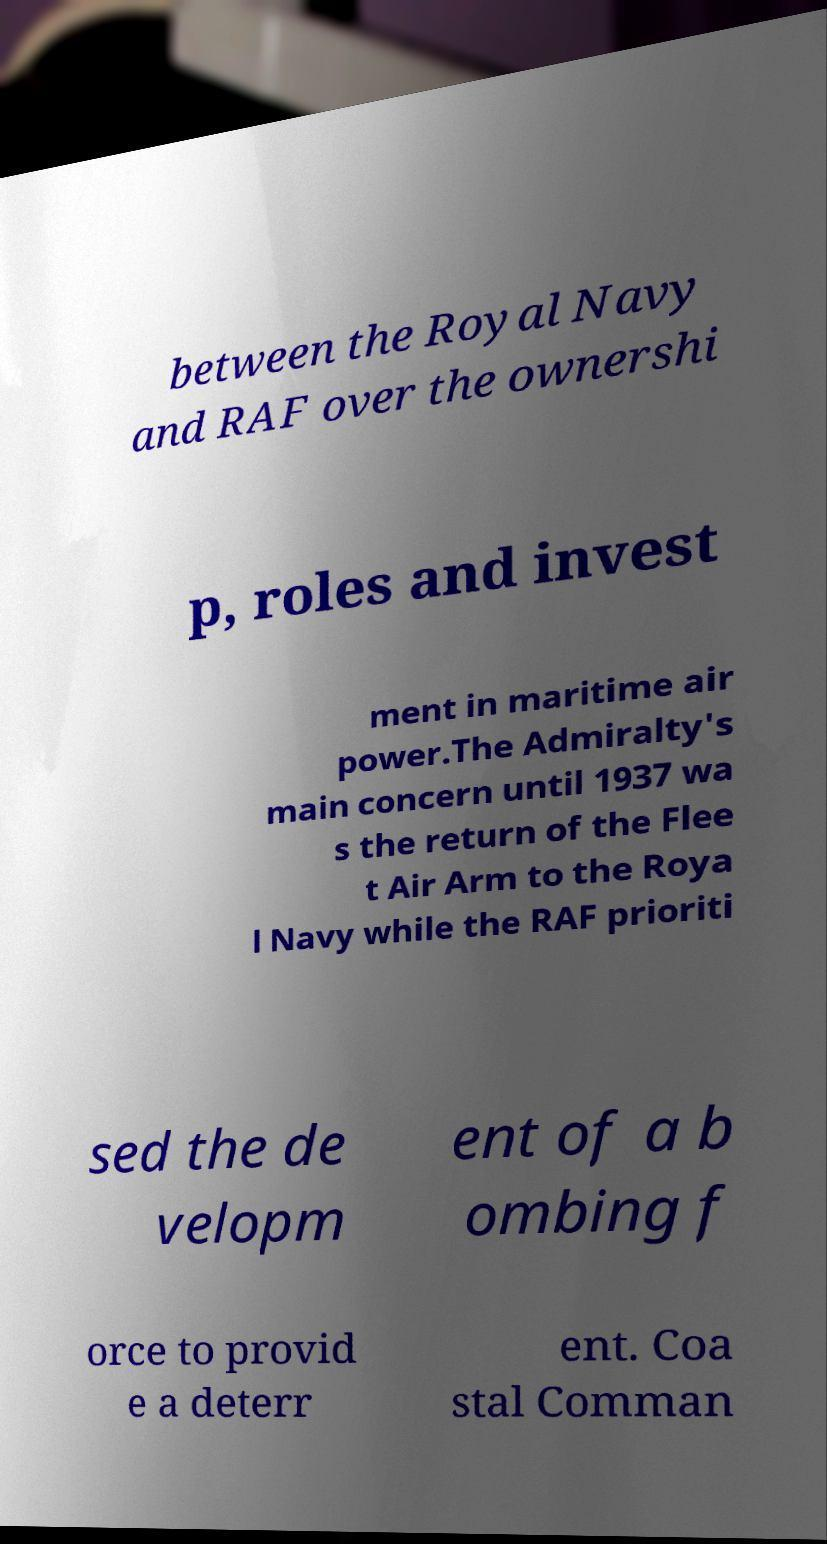I need the written content from this picture converted into text. Can you do that? between the Royal Navy and RAF over the ownershi p, roles and invest ment in maritime air power.The Admiralty's main concern until 1937 wa s the return of the Flee t Air Arm to the Roya l Navy while the RAF prioriti sed the de velopm ent of a b ombing f orce to provid e a deterr ent. Coa stal Comman 